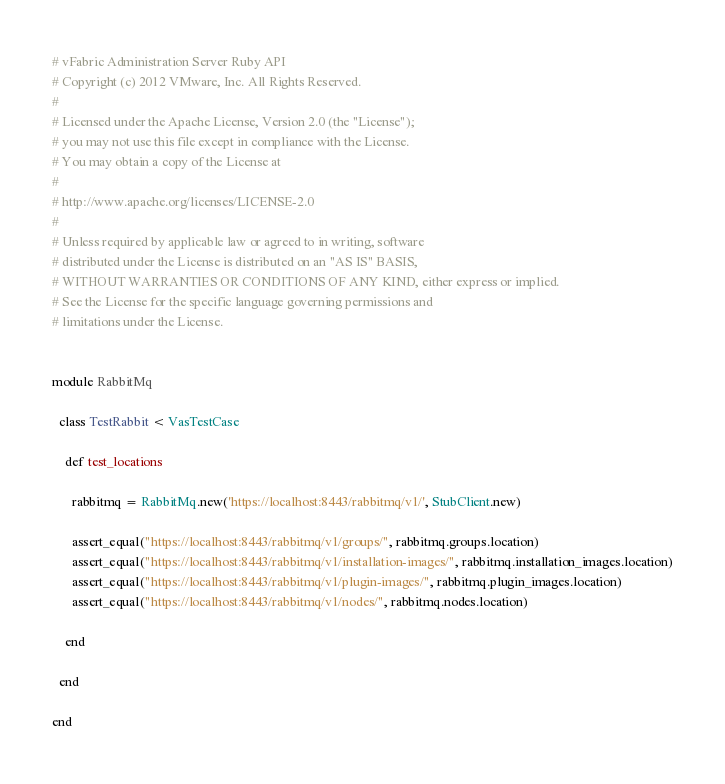<code> <loc_0><loc_0><loc_500><loc_500><_Ruby_># vFabric Administration Server Ruby API
# Copyright (c) 2012 VMware, Inc. All Rights Reserved.
#
# Licensed under the Apache License, Version 2.0 (the "License");
# you may not use this file except in compliance with the License.
# You may obtain a copy of the License at
#
# http://www.apache.org/licenses/LICENSE-2.0
#
# Unless required by applicable law or agreed to in writing, software
# distributed under the License is distributed on an "AS IS" BASIS,
# WITHOUT WARRANTIES OR CONDITIONS OF ANY KIND, either express or implied.
# See the License for the specific language governing permissions and
# limitations under the License.


module RabbitMq
  
  class TestRabbit < VasTestCase
  
    def test_locations
  
      rabbitmq = RabbitMq.new('https://localhost:8443/rabbitmq/v1/', StubClient.new)
      
      assert_equal("https://localhost:8443/rabbitmq/v1/groups/", rabbitmq.groups.location)
      assert_equal("https://localhost:8443/rabbitmq/v1/installation-images/", rabbitmq.installation_images.location)
      assert_equal("https://localhost:8443/rabbitmq/v1/plugin-images/", rabbitmq.plugin_images.location)
      assert_equal("https://localhost:8443/rabbitmq/v1/nodes/", rabbitmq.nodes.location)

    end
  
  end
  
end</code> 